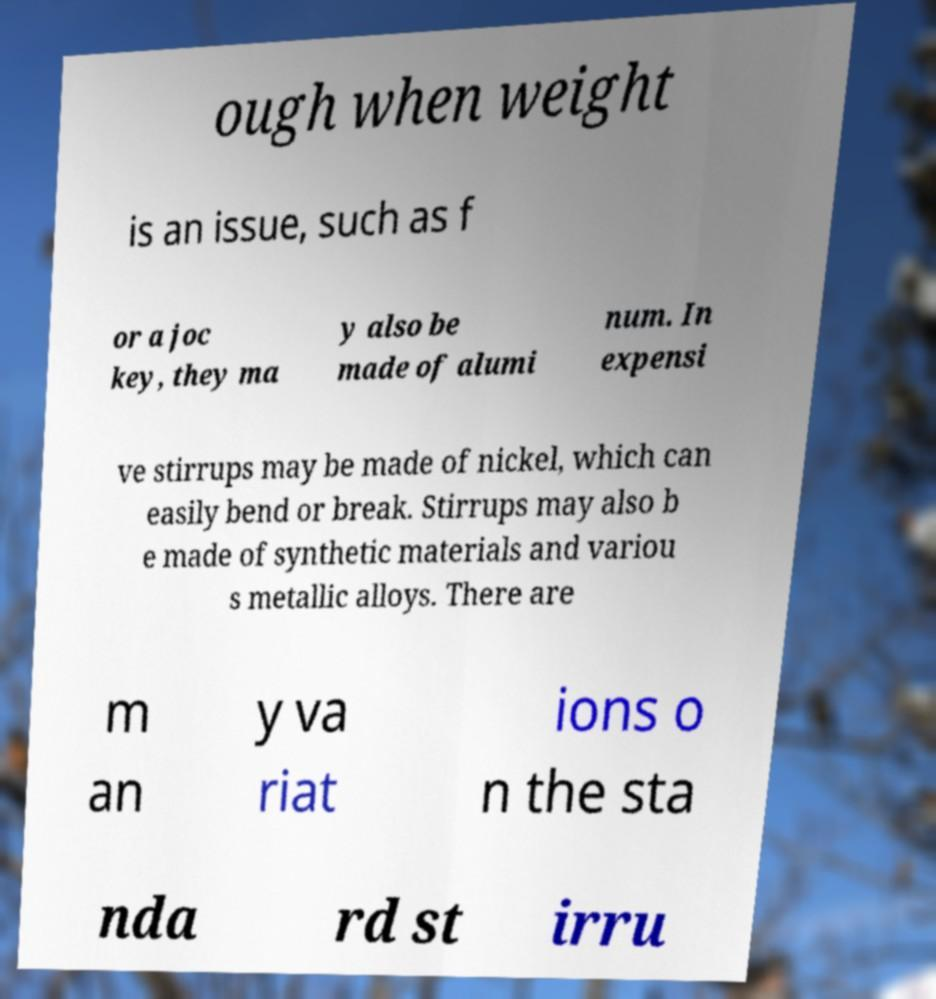Please identify and transcribe the text found in this image. ough when weight is an issue, such as f or a joc key, they ma y also be made of alumi num. In expensi ve stirrups may be made of nickel, which can easily bend or break. Stirrups may also b e made of synthetic materials and variou s metallic alloys. There are m an y va riat ions o n the sta nda rd st irru 